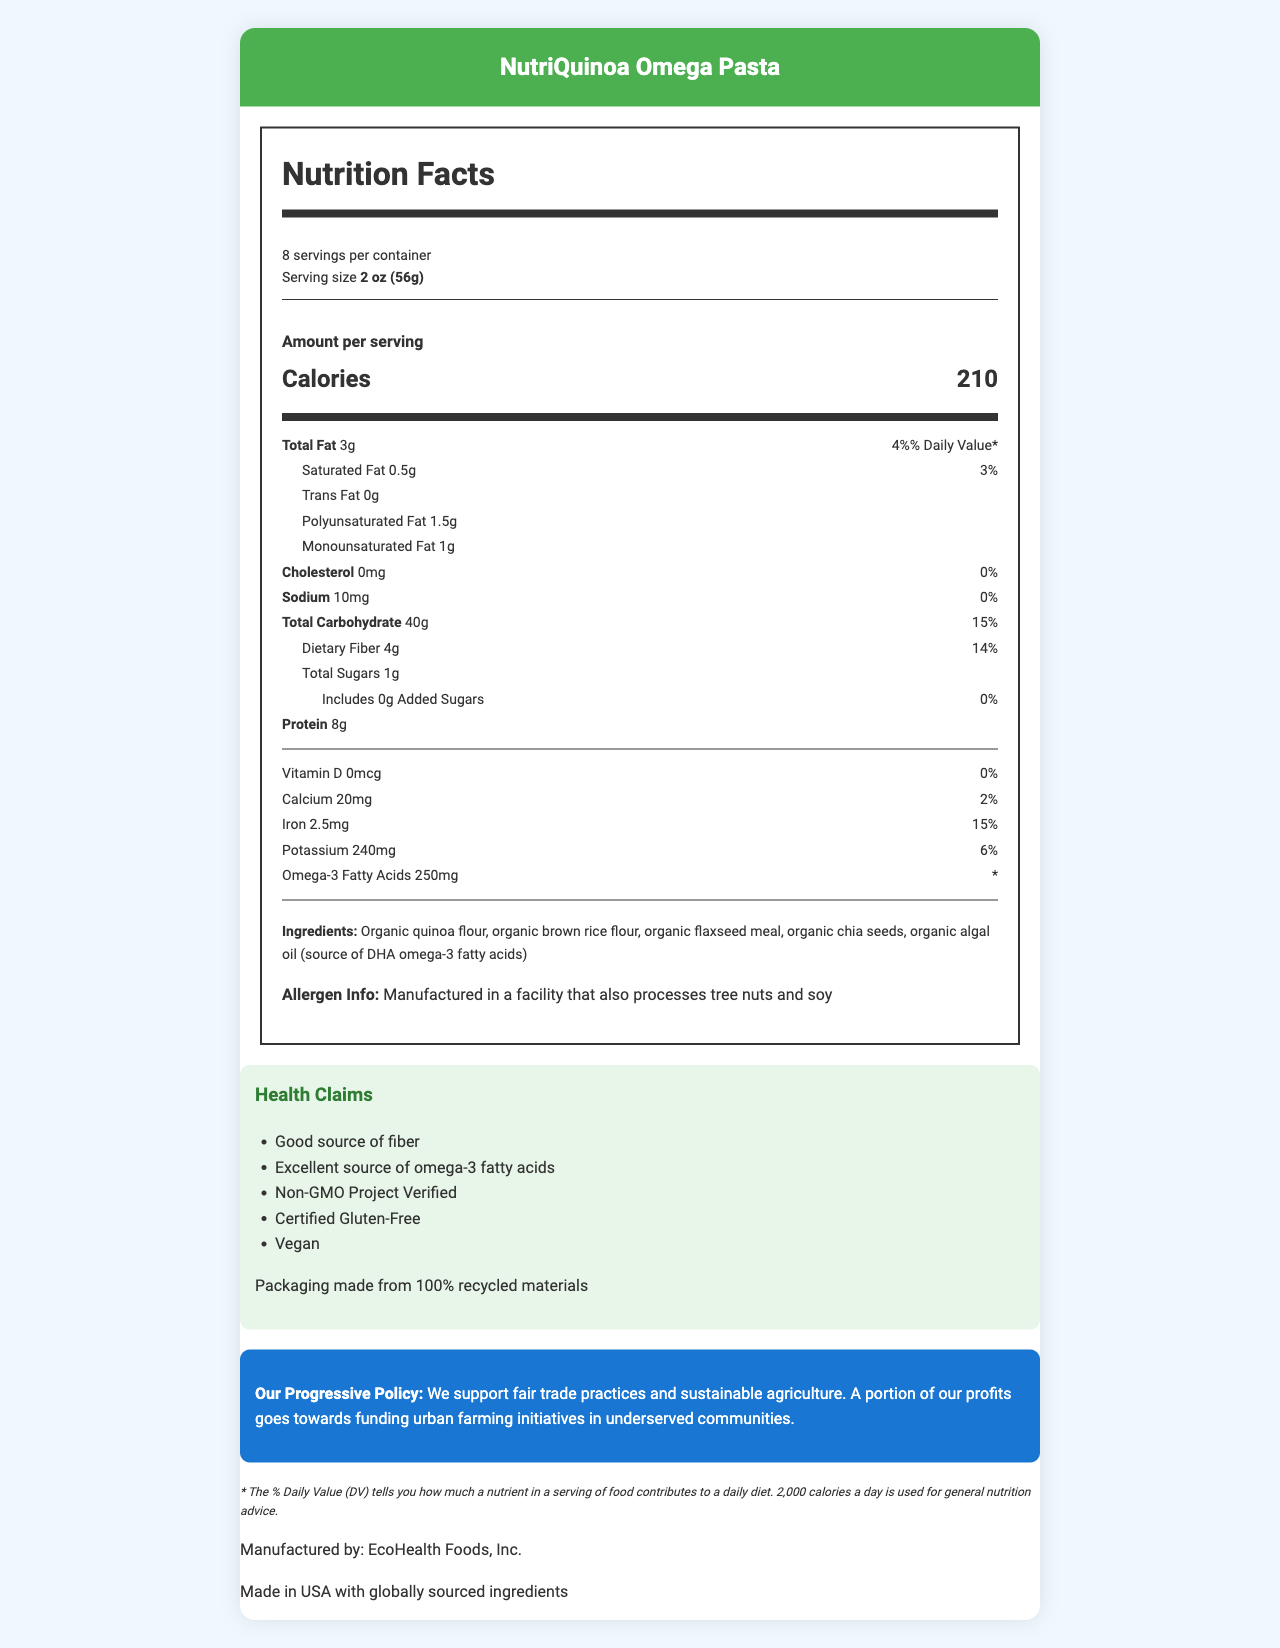what is the serving size of NutriQuinoa Omega Pasta? The serving size is listed under the serving information section as "2 oz (56g)".
Answer: 2 oz (56g) how many servings are there in a container? The document states that there are 8 servings per container.
Answer: 8 What percentage of the daily value for dietary fiber does one serving provide? The daily value percentage for dietary fiber is listed as 14%.
Answer: 14% What is the main ingredient in NutriQuinoa Omega Pasta? The ingredients list starts with "Organic quinoa flour," indicating it is the main ingredient.
Answer: Organic quinoa flour how much protein is in one serving? One serving of the pasta contains 8 grams of protein.
Answer: 8g Which of the following is NOT a health claim made by NutriQuinoa Omega Pasta? A. Good source of fiber B. High in trans fats C. Vegan D. Certified Gluten-Free The health claims include "Good source of fiber", "Vegan", and "Certified Gluten-Free" but nothing about being high in trans fats.
Answer: B Which nutrient does not contribute to the daily value percentage? A. Omega-3 Fatty Acids B. Iron C. Calcium D. Dietary Fiber The daily value percentage for Omega-3 Fatty Acids is marked with an asterisk, indicating it’s not provided.
Answer: A Is this product vegan? The health claims list includes "Vegan".
Answer: Yes Summarize the main nutritional highlights of NutriQuinoa Omega Pasta. This summary includes the main nutrients per serving as well as the health claims and progressive policy statement.
Answer: NutriQuinoa Omega Pasta provides 210 calories per serving, with 3g of total fat, 8g of protein, and 40g of total carbohydrates including 4g of dietary fiber. It also contains 250mg of omega-3 fatty acids and is advertised as non-GMO, gluten-free, and vegan. Additionally, it supports sustainable agriculture and urban farming initiatives. How is the product packaged? The sustainability information states that the packaging is made from 100% recycled materials.
Answer: Packaging made from 100% recycled materials What is the source of DHA omega-3 fatty acids in this product? The ingredients list includes "organic algal oil" as the source of DHA omega-3 fatty acids.
Answer: Organic algal oil Where is the product manufactured? The document specifies that the product is made in the USA with globally sourced ingredients.
Answer: Made in USA What is the amount of trans fat in a serving? The document lists trans fat content as 0 grams.
Answer: 0g How much calcium is in one serving, and what is its daily value percentage? One serving contains 20mg of calcium, which corresponds to 2% of the daily value.
Answer: 20mg, 2% Can the exact percentage of omega-3 fatty acids per daily value be determined from the document? The document marks the daily value of omega-3 fatty acids with an asterisk, indicating that it’s not provided.
Answer: No 